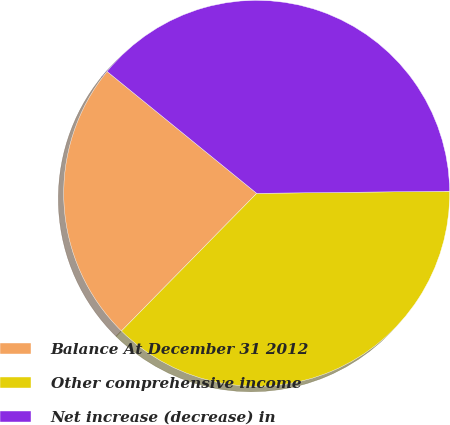Convert chart to OTSL. <chart><loc_0><loc_0><loc_500><loc_500><pie_chart><fcel>Balance At December 31 2012<fcel>Other comprehensive income<fcel>Net increase (decrease) in<nl><fcel>23.52%<fcel>37.54%<fcel>38.94%<nl></chart> 